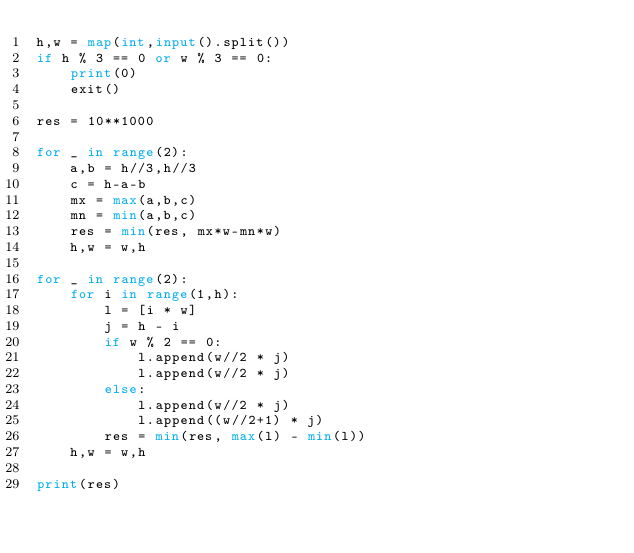<code> <loc_0><loc_0><loc_500><loc_500><_Python_>h,w = map(int,input().split())
if h % 3 == 0 or w % 3 == 0:
    print(0)
    exit()

res = 10**1000

for _ in range(2):
    a,b = h//3,h//3
    c = h-a-b
    mx = max(a,b,c)
    mn = min(a,b,c)
    res = min(res, mx*w-mn*w)
    h,w = w,h

for _ in range(2):
    for i in range(1,h):
        l = [i * w]
        j = h - i
        if w % 2 == 0:
            l.append(w//2 * j)
            l.append(w//2 * j)
        else:
            l.append(w//2 * j)
            l.append((w//2+1) * j)
        res = min(res, max(l) - min(l))
    h,w = w,h

print(res)
</code> 